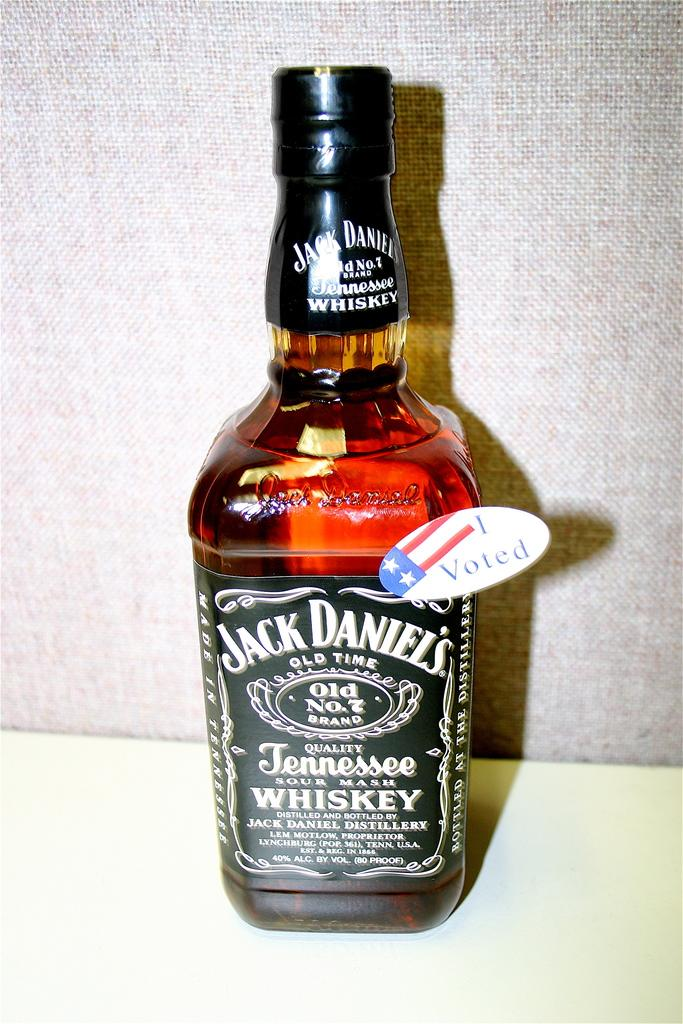<image>
Present a compact description of the photo's key features. i voted sticker attached to bottle of jack daniels tennessee whiskey 